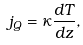<formula> <loc_0><loc_0><loc_500><loc_500>j _ { Q } = \kappa \frac { d T } { d z } ,</formula> 